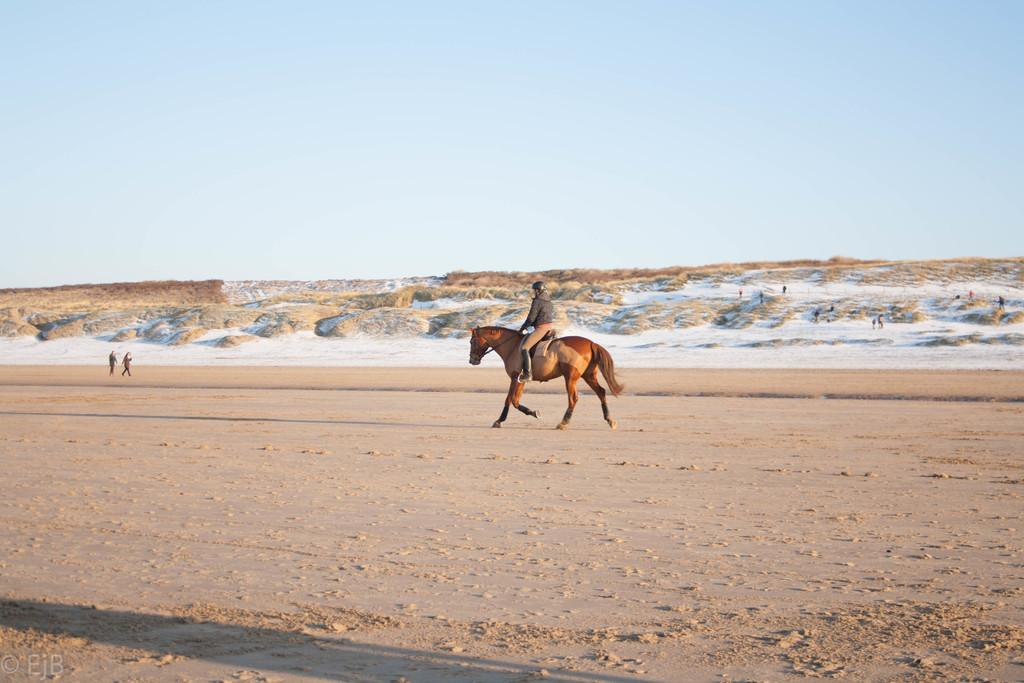What is the main subject of the image? There is a person in the image. What is the person doing in the image? The person is riding a horse. Can you describe the horse in the image? The horse is brown in color. What is visible at the top of the image? The sky is visible at the top of the image. Can you tell me how many grapes are on the horse's saddle in the image? There are no grapes present in the image, and the horse's saddle is not visible. What type of bird can be seen flying in the winter sky in the image? The image does not depict a winter sky or any birds, so it is not possible to answer that question. 